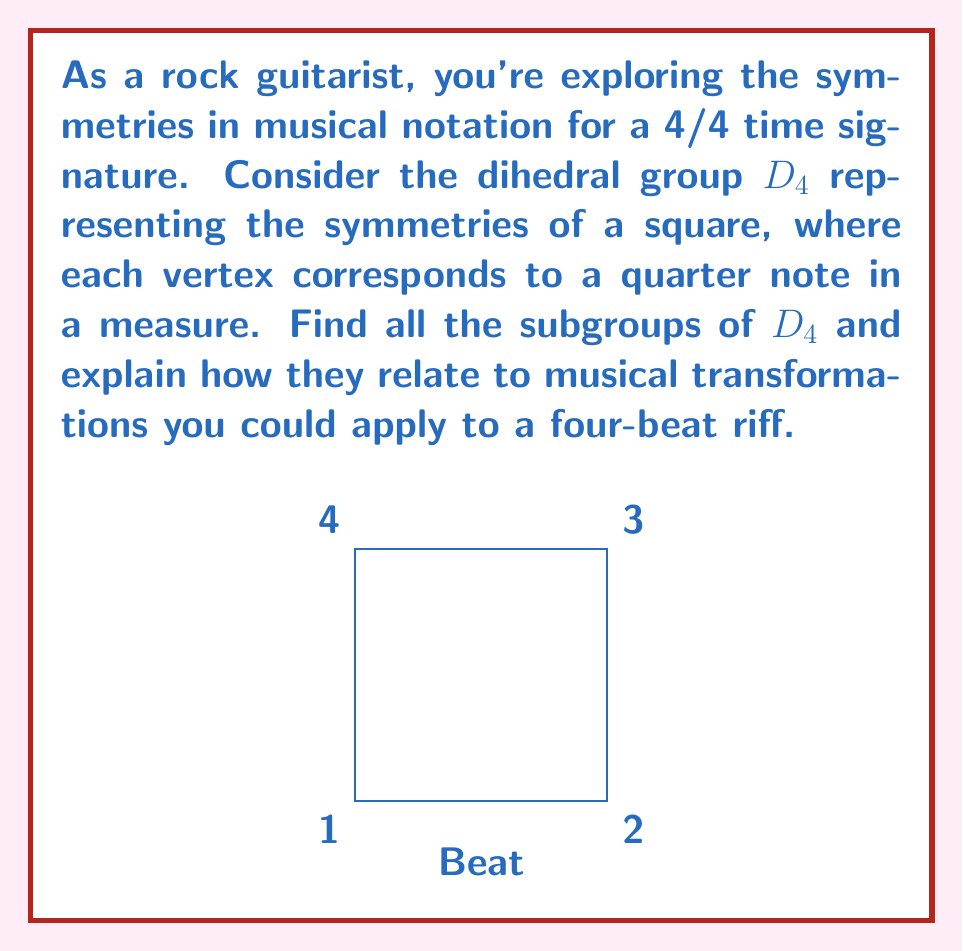Could you help me with this problem? Let's approach this step-by-step:

1) First, recall that $D_4$ has 8 elements: 
   - 4 rotations: $e$ (identity), $r$ (90° clockwise), $r^2$ (180°), $r^3$ (270° clockwise)
   - 4 reflections: $s$ (vertical), $sr$ (diagonal), $sr^2$ (horizontal), $sr^3$ (other diagonal)

2) To find all subgroups, we need to consider all possible combinations of these elements that form closed sets under the group operation.

3) The subgroups of $D_4$ are:

   a) $\{e\}$ - Trivial subgroup (order 1)
      Musical interpretation: No change to the riff

   b) $\{e, r^2\}$ - Cyclic subgroup of order 2
      Musical interpretation: Swapping beats 1 with 3, and 2 with 4

   c) $\{e, s\}$, $\{e, sr^2\}$ - Two more subgroups of order 2
      Musical interpretation: Vertical reflection (reversing the riff) and horizontal reflection (swapping first half with second half)

   d) $\{e, sr, r^2, sr^3\}$ - Klein four-group
      Musical interpretation: Combinations of diagonal reflections and 180° rotation

   e) $\{e, r, r^2, r^3\}$ - Cyclic subgroup of order 4
      Musical interpretation: All rotations, which could represent playing the riff starting from different beats

   f) $D_4$ itself - The full group (order 8)
      Musical interpretation: All possible symmetry transformations

4) Each of these subgroups represents a set of transformations that could be applied to a four-beat riff while maintaining some form of symmetry.

5) For a rock guitarist, these transformations could inspire creative variations on a basic riff, such as playing it backwards (vertical reflection), shifting the starting point (rotations), or creating palindromic patterns (horizontal reflection).
Answer: The subgroups of $D_4$ are: $\{e\}$, $\{e, r^2\}$, $\{e, s\}$, $\{e, sr^2\}$, $\{e, sr, r^2, sr^3\}$, $\{e, r, r^2, r^3\}$, and $D_4$ itself. 